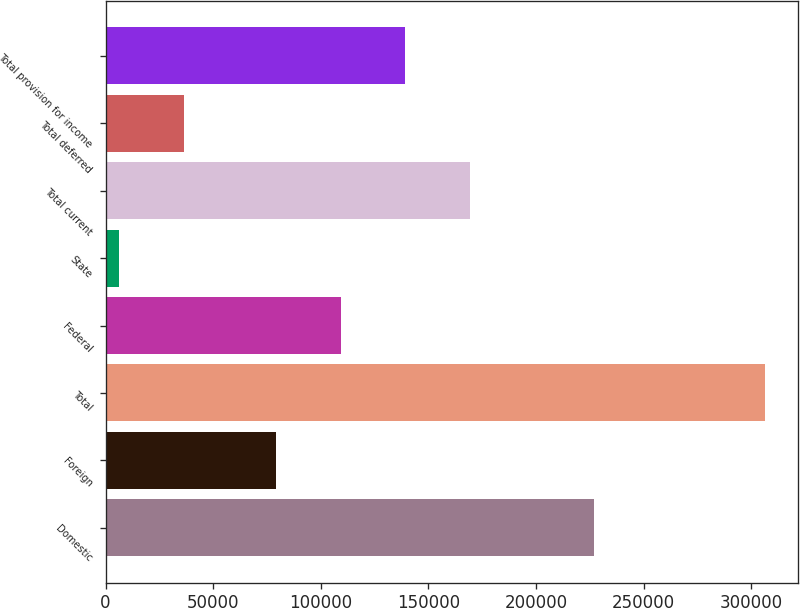<chart> <loc_0><loc_0><loc_500><loc_500><bar_chart><fcel>Domestic<fcel>Foreign<fcel>Total<fcel>Federal<fcel>State<fcel>Total current<fcel>Total deferred<fcel>Total provision for income<nl><fcel>227044<fcel>79225<fcel>306269<fcel>109216<fcel>6362<fcel>169197<fcel>36352.7<fcel>139206<nl></chart> 